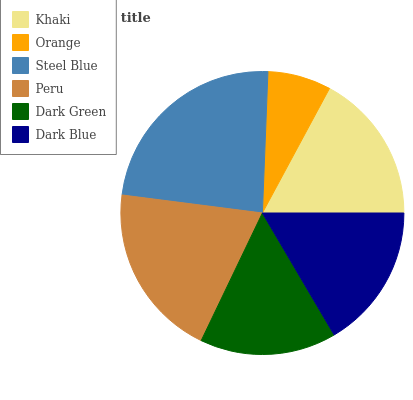Is Orange the minimum?
Answer yes or no. Yes. Is Steel Blue the maximum?
Answer yes or no. Yes. Is Steel Blue the minimum?
Answer yes or no. No. Is Orange the maximum?
Answer yes or no. No. Is Steel Blue greater than Orange?
Answer yes or no. Yes. Is Orange less than Steel Blue?
Answer yes or no. Yes. Is Orange greater than Steel Blue?
Answer yes or no. No. Is Steel Blue less than Orange?
Answer yes or no. No. Is Khaki the high median?
Answer yes or no. Yes. Is Dark Blue the low median?
Answer yes or no. Yes. Is Steel Blue the high median?
Answer yes or no. No. Is Orange the low median?
Answer yes or no. No. 